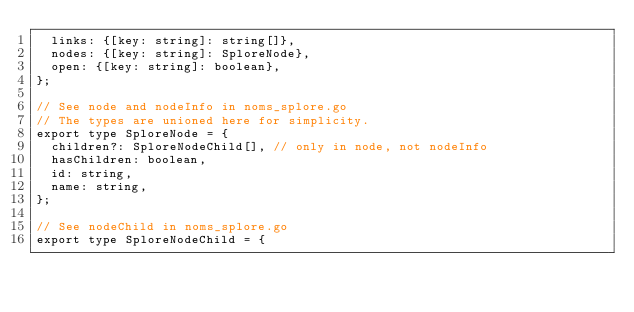<code> <loc_0><loc_0><loc_500><loc_500><_JavaScript_>  links: {[key: string]: string[]},
  nodes: {[key: string]: SploreNode},
  open: {[key: string]: boolean},
};

// See node and nodeInfo in noms_splore.go
// The types are unioned here for simplicity.
export type SploreNode = {
  children?: SploreNodeChild[], // only in node, not nodeInfo
  hasChildren: boolean,
  id: string,
  name: string,
};

// See nodeChild in noms_splore.go
export type SploreNodeChild = {</code> 